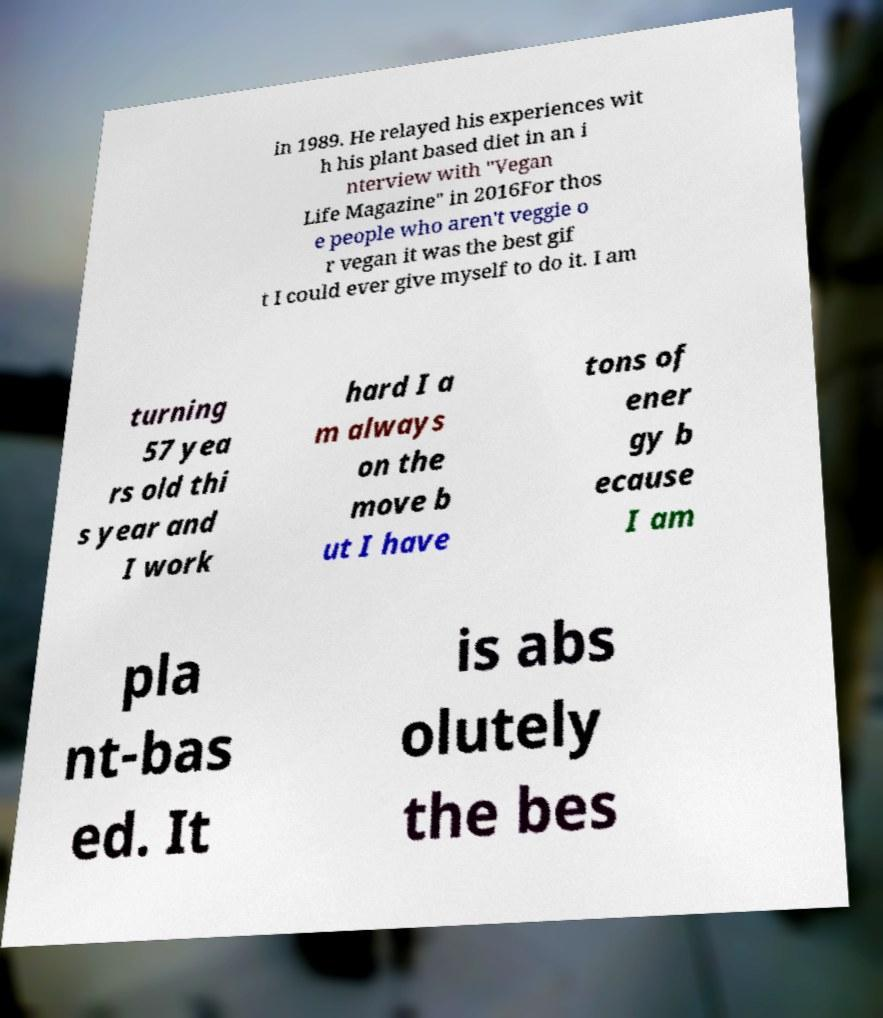Please read and relay the text visible in this image. What does it say? in 1989. He relayed his experiences wit h his plant based diet in an i nterview with "Vegan Life Magazine" in 2016For thos e people who aren't veggie o r vegan it was the best gif t I could ever give myself to do it. I am turning 57 yea rs old thi s year and I work hard I a m always on the move b ut I have tons of ener gy b ecause I am pla nt-bas ed. It is abs olutely the bes 